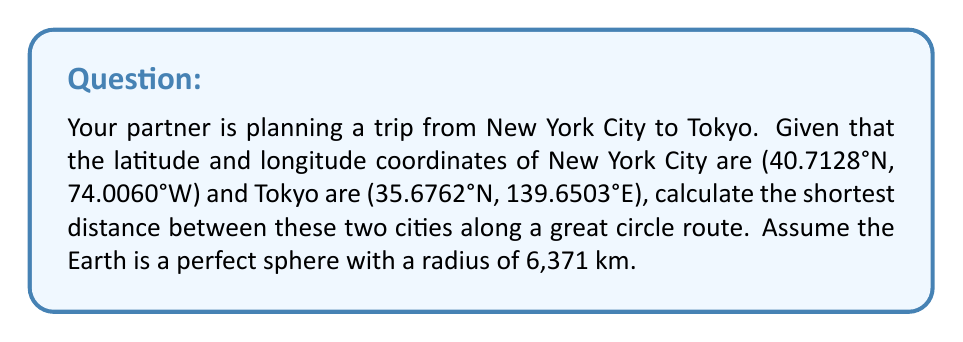Show me your answer to this math problem. To find the shortest distance between two points on a sphere, we use the great circle distance formula. This is perfect for calculating the distance between two cities on our approximately spherical Earth. Let's approach this step-by-step:

1) First, we need to convert the latitude and longitude coordinates from degrees to radians:

   New York: $\phi_1 = 40.7128° \times \frac{\pi}{180} = 0.7104$ rad
             $\lambda_1 = -74.0060° \times \frac{\pi}{180} = -1.2917$ rad
   
   Tokyo:    $\phi_2 = 35.6762° \times \frac{\pi}{180} = 0.6228$ rad
             $\lambda_2 = 139.6503° \times \frac{\pi}{180} = 2.4372$ rad

2) Next, we calculate the central angle $\Delta\sigma$ using the Haversine formula:

   $$\Delta\sigma = 2 \arcsin\left(\sqrt{\sin^2\left(\frac{\phi_2-\phi_1}{2}\right) + \cos\phi_1 \cos\phi_2 \sin^2\left(\frac{\lambda_2-\lambda_1}{2}\right)}\right)$$

3) Let's calculate each part:

   $\frac{\phi_2-\phi_1}{2} = \frac{0.6228 - 0.7104}{2} = -0.0438$
   $\sin^2\left(\frac{\phi_2-\phi_1}{2}\right) = \sin^2(-0.0438) = 0.0019$

   $\cos\phi_1 = \cos(0.7104) = 0.7578$
   $\cos\phi_2 = \cos(0.6228) = 0.8090$

   $\frac{\lambda_2-\lambda_1}{2} = \frac{2.4372 - (-1.2917)}{2} = 1.8645$
   $\sin^2\left(\frac{\lambda_2-\lambda_1}{2}\right) = \sin^2(1.8645) = 0.8246$

4) Putting these values into the Haversine formula:

   $$\Delta\sigma = 2 \arcsin\left(\sqrt{0.0019 + 0.7578 \times 0.8090 \times 0.8246}\right) = 1.9769$$

5) Finally, to get the distance $d$, we multiply the central angle by the Earth's radius:

   $$d = R \times \Delta\sigma = 6371 \times 1.9769 = 12594.13\text{ km}$$

Thus, the shortest distance between New York City and Tokyo along a great circle route is approximately 12,594 km.
Answer: 12,594 km 